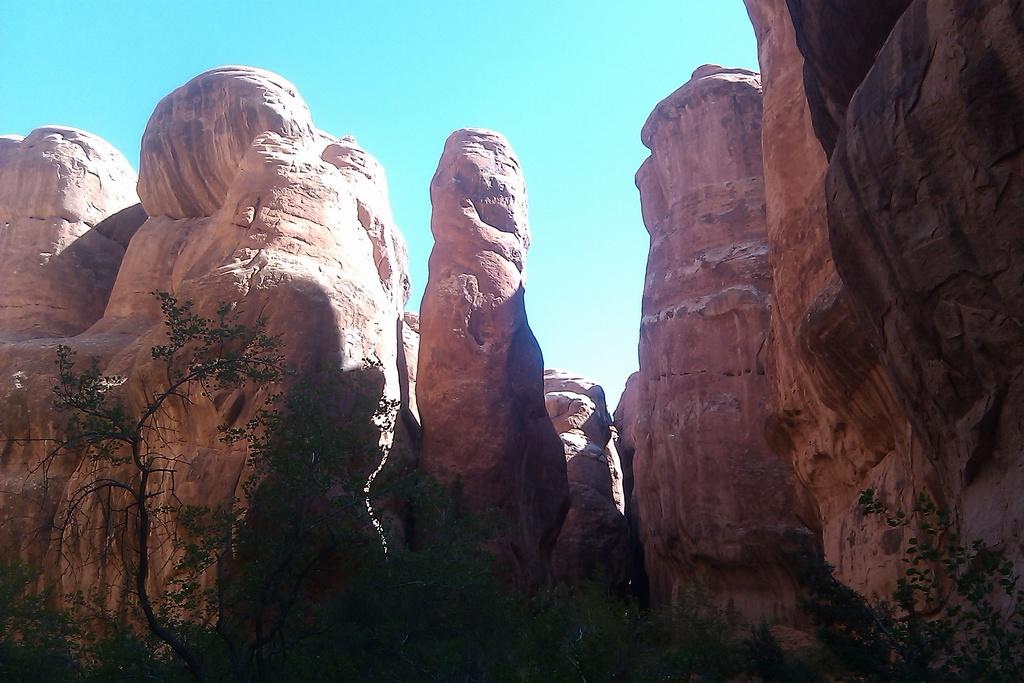What can be seen in the foreground of the image? There are trees in the foreground of the image. What type of natural elements are visible in the image? Rocks are visible in the image. What is visible in the sky in the image? Clouds are present in the sky in the image. What page number is the kettle mentioned on in the image? There is no page or kettle present in the image, as it is a photograph of a natural scene. 